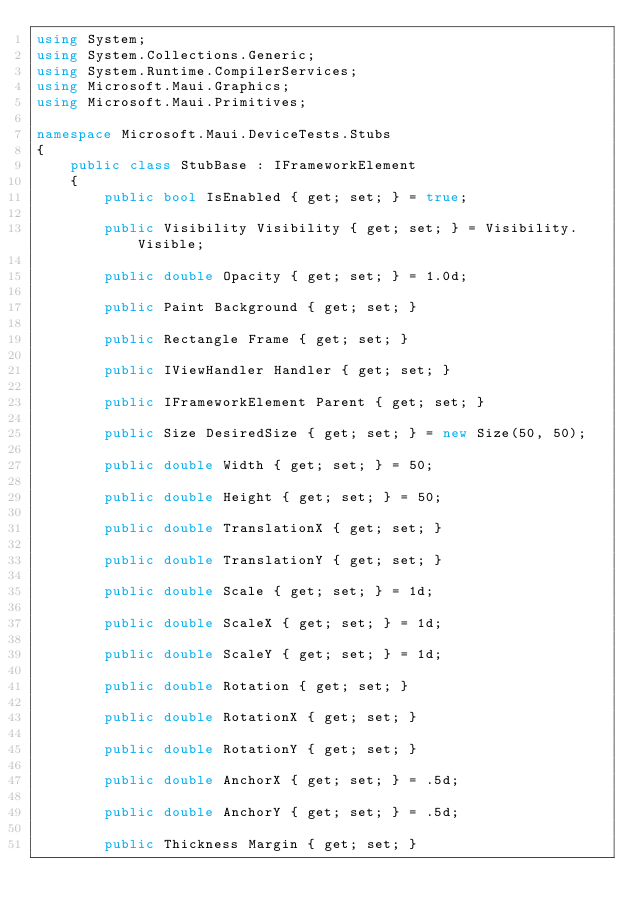<code> <loc_0><loc_0><loc_500><loc_500><_C#_>using System;
using System.Collections.Generic;
using System.Runtime.CompilerServices;
using Microsoft.Maui.Graphics;
using Microsoft.Maui.Primitives;

namespace Microsoft.Maui.DeviceTests.Stubs
{
	public class StubBase : IFrameworkElement
	{
		public bool IsEnabled { get; set; } = true;

		public Visibility Visibility { get; set; } = Visibility.Visible;

		public double Opacity { get; set; } = 1.0d;

		public Paint Background { get; set; }

		public Rectangle Frame { get; set; }

		public IViewHandler Handler { get; set; }

		public IFrameworkElement Parent { get; set; }

		public Size DesiredSize { get; set; } = new Size(50, 50);

		public double Width { get; set; } = 50;

		public double Height { get; set; } = 50;

		public double TranslationX { get; set; }

		public double TranslationY { get; set; }

		public double Scale { get; set; } = 1d;

		public double ScaleX { get; set; } = 1d;

		public double ScaleY { get; set; } = 1d;

		public double Rotation { get; set; }

		public double RotationX { get; set; }

		public double RotationY { get; set; }

		public double AnchorX { get; set; } = .5d;

		public double AnchorY { get; set; } = .5d;

		public Thickness Margin { get; set; }
</code> 